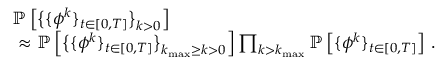Convert formula to latex. <formula><loc_0><loc_0><loc_500><loc_500>\begin{array} { r l } & { \mathbb { P } \left [ \left \{ \{ { \phi } ^ { k } \} _ { t \in [ 0 , T ] } \right \} _ { k > 0 } \right ] } \\ & { \approx \mathbb { P } \left [ \left \{ \{ { \phi } ^ { k } \} _ { t \in [ 0 , T ] } \right \} _ { k _ { \max } \geq k > 0 } \right ] \prod _ { k > k _ { \max } } \mathbb { P } \left [ \{ { \phi } ^ { k } \} _ { t \in [ 0 , T ] } \right ] \, . } \end{array}</formula> 